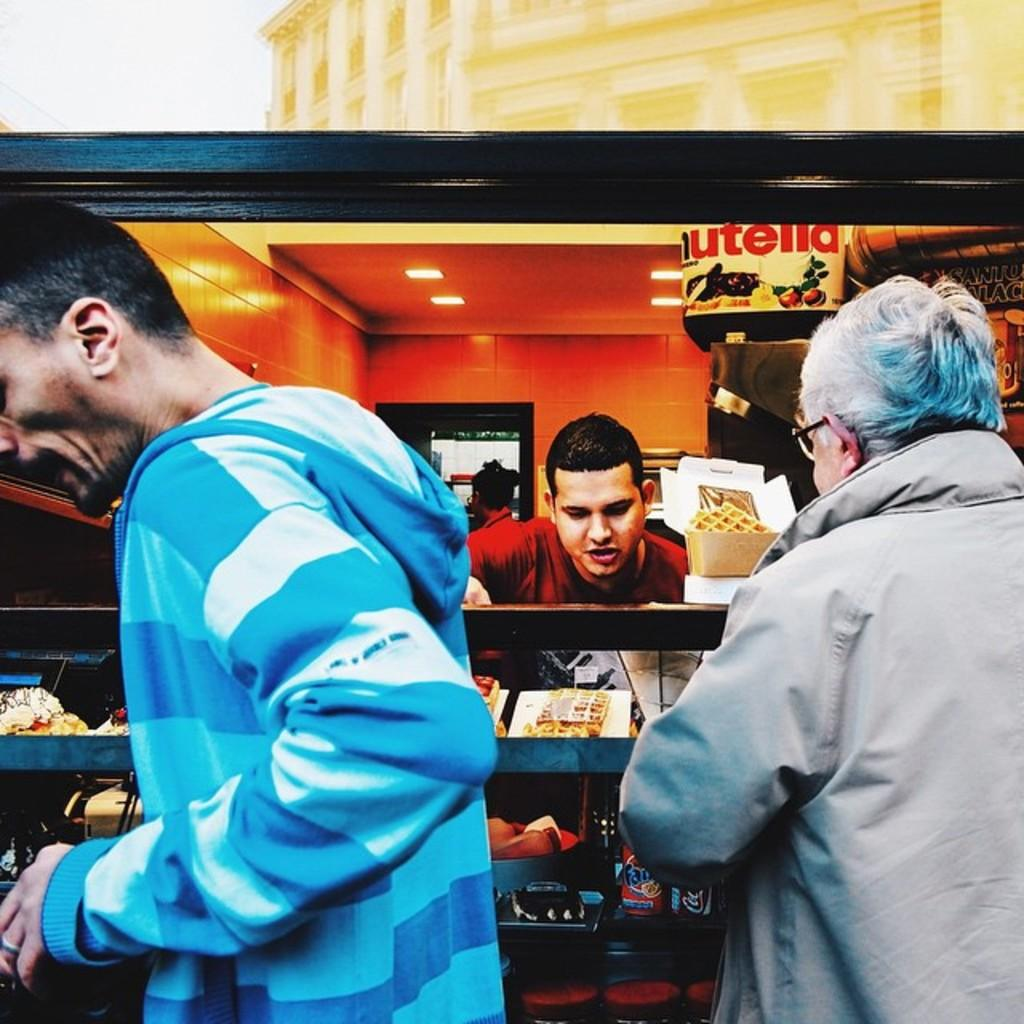What is happening in the image? There are people standing near a food stall in the image. What can be seen on the food stall? Food items are present in the image. How are the food items displayed? The food items are kept on a glass table. What type of nail is being used by the farmer in the image? There is no farmer or nail present in the image; it features people standing near a food stall with food items on a glass table. 